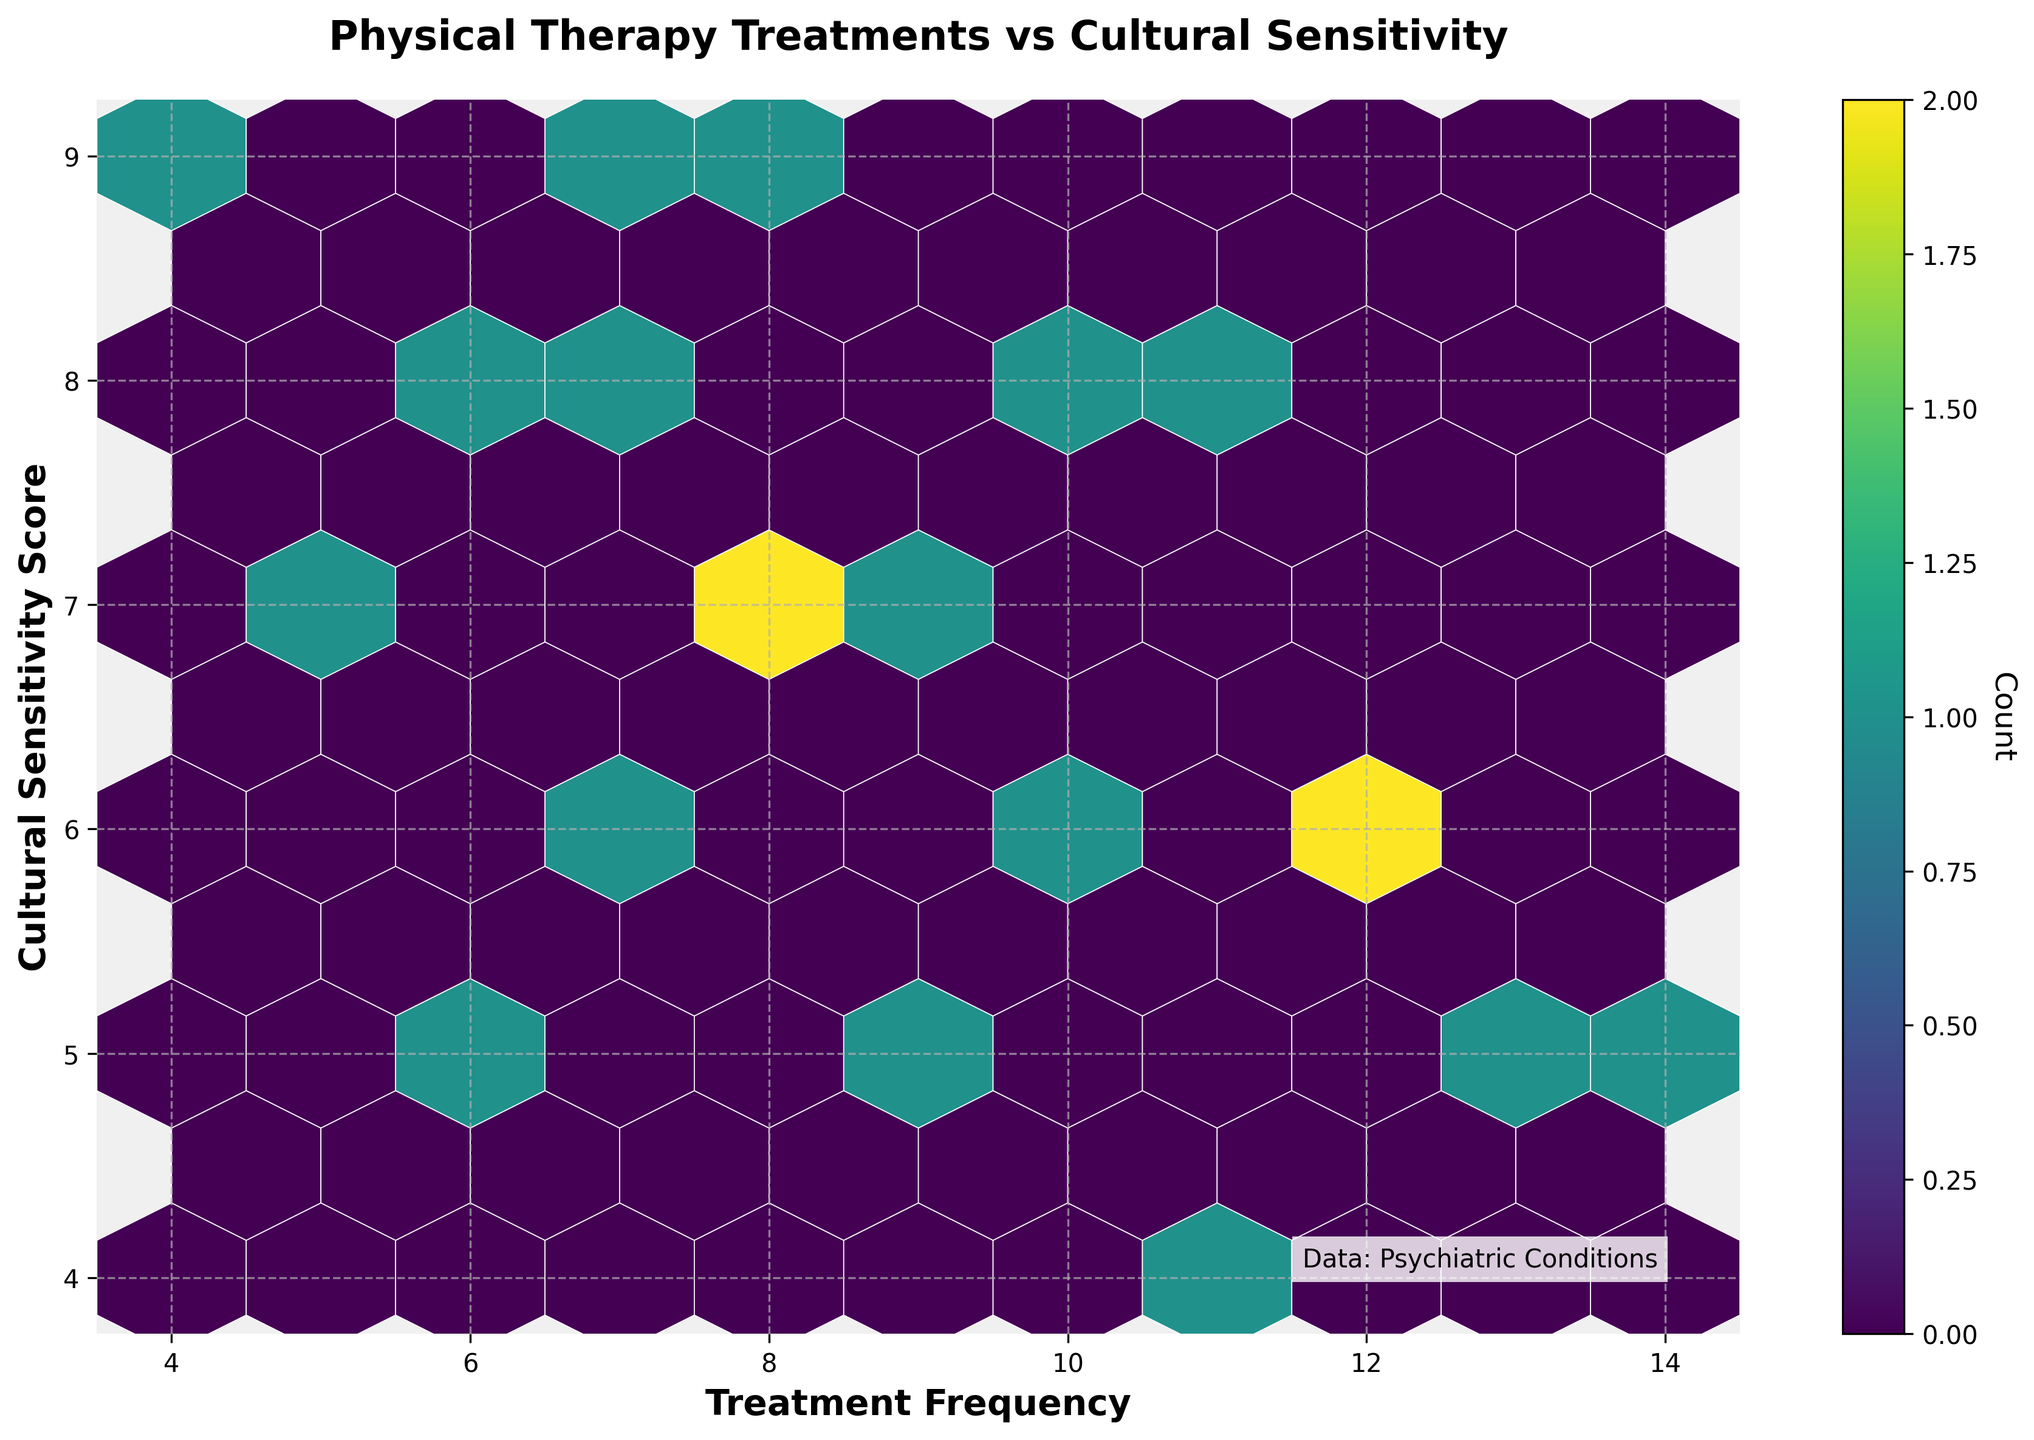How many distinct bins are there in the hexbin plot? Look at the hexagonal cells on the plot to count them or judge their distinctness. It is possible to roughly estimate from the coloring and size of the hexagons.
Answer: The number of distinct bins is approximately between 25 and 35 What is the title of the figure? The title is usually located at the top center of the plot and is used to describe the content or purpose of the plot.
Answer: Physical Therapy Treatments vs Cultural Sensitivity Which axis represents the "Treatment Frequency"? Generally, the x-axis is labeled and described below the horizontal line in the plot.
Answer: The x-axis What is the color of the grid lines in the plot? Grid lines are usually seen in the plotting area, and they provide a reference for estimating data points.
Answer: They are light gray in color What is the highest treatment frequency shown on the x-axis? Look to the furthest right label on the x-axis where the maximum value is indicated.
Answer: 14 How does "Cultural Sensitivity Score" relate to "Treatment Frequency"? One can infer from how the hexagons are distributed along the xy coordinates. A pattern could indicate a correlation.
Answer: Shows varying correlation, but no definitive trend Identify the range of "Cultural Sensitivity Score" in the data. The range can be determined by looking at the lowest and highest values on the y-axis.
Answer: 4 to 9 Which psychiatric condition corresponds to the highest "Treatment Frequency"? To answer this, closely examine the data point at the highest x-axis value and find its associated condition in the data table.
Answer: Generalized Anxiety Disorder Which "Cultural Sensitivity Score" appears most frequently across different treatment frequencies? Identify which horizontal line has the most hexagonal cells, as the concentration of points indicates frequency.
Answer: Score 7 Is there a treatment frequency that aligns with the highest count in the hexbin plot? Understand where the color intensity of the hexagonal cell is the greatest and map it to its x-value.
Answer: Treatment frequency of 8 